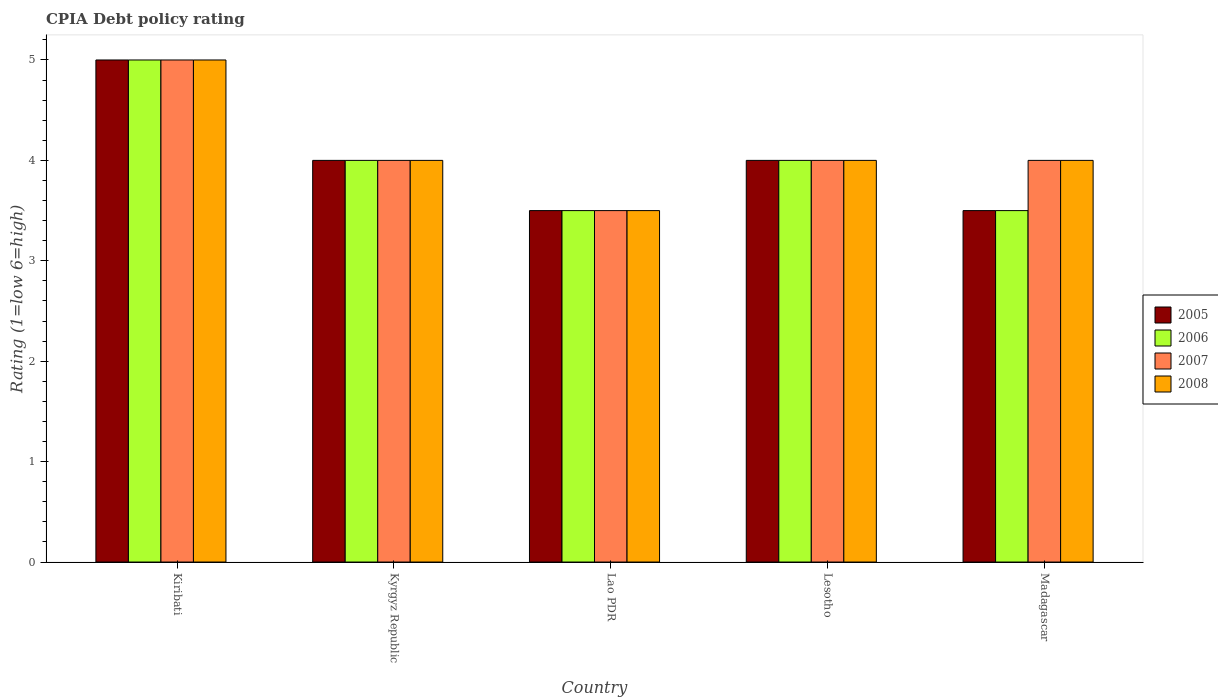How many groups of bars are there?
Make the answer very short. 5. Are the number of bars on each tick of the X-axis equal?
Give a very brief answer. Yes. How many bars are there on the 2nd tick from the left?
Make the answer very short. 4. How many bars are there on the 3rd tick from the right?
Offer a very short reply. 4. What is the label of the 1st group of bars from the left?
Provide a short and direct response. Kiribati. In how many cases, is the number of bars for a given country not equal to the number of legend labels?
Provide a short and direct response. 0. What is the CPIA rating in 2006 in Kyrgyz Republic?
Give a very brief answer. 4. In which country was the CPIA rating in 2008 maximum?
Your response must be concise. Kiribati. In which country was the CPIA rating in 2006 minimum?
Your response must be concise. Lao PDR. What is the total CPIA rating in 2005 in the graph?
Your answer should be very brief. 20. What is the difference between the CPIA rating in 2007 in Lao PDR and that in Madagascar?
Your answer should be compact. -0.5. What is the difference between the CPIA rating of/in 2007 and CPIA rating of/in 2005 in Madagascar?
Your answer should be very brief. 0.5. What is the ratio of the CPIA rating in 2007 in Lesotho to that in Madagascar?
Make the answer very short. 1. Is the CPIA rating in 2005 in Kiribati less than that in Lao PDR?
Give a very brief answer. No. What is the difference between the highest and the second highest CPIA rating in 2007?
Offer a very short reply. -1. What is the difference between the highest and the lowest CPIA rating in 2007?
Provide a succinct answer. 1.5. In how many countries, is the CPIA rating in 2006 greater than the average CPIA rating in 2006 taken over all countries?
Offer a terse response. 1. Is the sum of the CPIA rating in 2005 in Lao PDR and Madagascar greater than the maximum CPIA rating in 2006 across all countries?
Your response must be concise. Yes. Is it the case that in every country, the sum of the CPIA rating in 2006 and CPIA rating in 2008 is greater than the CPIA rating in 2005?
Your answer should be compact. Yes. How many bars are there?
Give a very brief answer. 20. Are all the bars in the graph horizontal?
Your answer should be very brief. No. How many countries are there in the graph?
Keep it short and to the point. 5. Are the values on the major ticks of Y-axis written in scientific E-notation?
Your answer should be compact. No. Where does the legend appear in the graph?
Provide a succinct answer. Center right. How are the legend labels stacked?
Your response must be concise. Vertical. What is the title of the graph?
Make the answer very short. CPIA Debt policy rating. Does "1981" appear as one of the legend labels in the graph?
Make the answer very short. No. What is the label or title of the X-axis?
Offer a very short reply. Country. What is the label or title of the Y-axis?
Make the answer very short. Rating (1=low 6=high). What is the Rating (1=low 6=high) of 2008 in Kiribati?
Your answer should be compact. 5. What is the Rating (1=low 6=high) in 2005 in Kyrgyz Republic?
Give a very brief answer. 4. What is the Rating (1=low 6=high) in 2007 in Kyrgyz Republic?
Ensure brevity in your answer.  4. What is the Rating (1=low 6=high) in 2008 in Kyrgyz Republic?
Your response must be concise. 4. What is the Rating (1=low 6=high) in 2005 in Lao PDR?
Provide a succinct answer. 3.5. What is the Rating (1=low 6=high) of 2006 in Lao PDR?
Offer a terse response. 3.5. What is the Rating (1=low 6=high) of 2008 in Lao PDR?
Give a very brief answer. 3.5. What is the Rating (1=low 6=high) of 2005 in Lesotho?
Your response must be concise. 4. What is the Rating (1=low 6=high) of 2007 in Lesotho?
Give a very brief answer. 4. What is the Rating (1=low 6=high) of 2005 in Madagascar?
Ensure brevity in your answer.  3.5. What is the Rating (1=low 6=high) in 2007 in Madagascar?
Offer a very short reply. 4. What is the Rating (1=low 6=high) in 2008 in Madagascar?
Offer a terse response. 4. Across all countries, what is the maximum Rating (1=low 6=high) in 2007?
Keep it short and to the point. 5. Across all countries, what is the minimum Rating (1=low 6=high) of 2005?
Provide a short and direct response. 3.5. Across all countries, what is the minimum Rating (1=low 6=high) of 2006?
Keep it short and to the point. 3.5. What is the total Rating (1=low 6=high) in 2005 in the graph?
Your answer should be compact. 20. What is the total Rating (1=low 6=high) in 2007 in the graph?
Offer a very short reply. 20.5. What is the difference between the Rating (1=low 6=high) of 2006 in Kiribati and that in Lao PDR?
Provide a succinct answer. 1.5. What is the difference between the Rating (1=low 6=high) of 2007 in Kiribati and that in Lao PDR?
Offer a terse response. 1.5. What is the difference between the Rating (1=low 6=high) of 2006 in Kiribati and that in Lesotho?
Your answer should be very brief. 1. What is the difference between the Rating (1=low 6=high) in 2007 in Kiribati and that in Lesotho?
Your answer should be compact. 1. What is the difference between the Rating (1=low 6=high) in 2005 in Kiribati and that in Madagascar?
Offer a terse response. 1.5. What is the difference between the Rating (1=low 6=high) of 2006 in Kiribati and that in Madagascar?
Make the answer very short. 1.5. What is the difference between the Rating (1=low 6=high) in 2008 in Kiribati and that in Madagascar?
Give a very brief answer. 1. What is the difference between the Rating (1=low 6=high) of 2005 in Kyrgyz Republic and that in Lao PDR?
Your response must be concise. 0.5. What is the difference between the Rating (1=low 6=high) in 2006 in Kyrgyz Republic and that in Lao PDR?
Your response must be concise. 0.5. What is the difference between the Rating (1=low 6=high) of 2006 in Kyrgyz Republic and that in Lesotho?
Provide a succinct answer. 0. What is the difference between the Rating (1=low 6=high) of 2008 in Kyrgyz Republic and that in Madagascar?
Ensure brevity in your answer.  0. What is the difference between the Rating (1=low 6=high) of 2006 in Lao PDR and that in Lesotho?
Offer a very short reply. -0.5. What is the difference between the Rating (1=low 6=high) in 2008 in Lao PDR and that in Lesotho?
Your response must be concise. -0.5. What is the difference between the Rating (1=low 6=high) in 2006 in Lao PDR and that in Madagascar?
Offer a terse response. 0. What is the difference between the Rating (1=low 6=high) in 2008 in Lao PDR and that in Madagascar?
Your answer should be compact. -0.5. What is the difference between the Rating (1=low 6=high) in 2006 in Lesotho and that in Madagascar?
Your answer should be very brief. 0.5. What is the difference between the Rating (1=low 6=high) in 2008 in Lesotho and that in Madagascar?
Give a very brief answer. 0. What is the difference between the Rating (1=low 6=high) in 2005 in Kiribati and the Rating (1=low 6=high) in 2008 in Kyrgyz Republic?
Ensure brevity in your answer.  1. What is the difference between the Rating (1=low 6=high) in 2006 in Kiribati and the Rating (1=low 6=high) in 2008 in Kyrgyz Republic?
Provide a short and direct response. 1. What is the difference between the Rating (1=low 6=high) of 2005 in Kiribati and the Rating (1=low 6=high) of 2006 in Lao PDR?
Offer a terse response. 1.5. What is the difference between the Rating (1=low 6=high) of 2005 in Kiribati and the Rating (1=low 6=high) of 2008 in Lao PDR?
Offer a terse response. 1.5. What is the difference between the Rating (1=low 6=high) of 2006 in Kiribati and the Rating (1=low 6=high) of 2007 in Lao PDR?
Your answer should be compact. 1.5. What is the difference between the Rating (1=low 6=high) in 2006 in Kiribati and the Rating (1=low 6=high) in 2008 in Lao PDR?
Your response must be concise. 1.5. What is the difference between the Rating (1=low 6=high) of 2007 in Kiribati and the Rating (1=low 6=high) of 2008 in Lao PDR?
Offer a terse response. 1.5. What is the difference between the Rating (1=low 6=high) of 2005 in Kiribati and the Rating (1=low 6=high) of 2007 in Lesotho?
Ensure brevity in your answer.  1. What is the difference between the Rating (1=low 6=high) in 2005 in Kiribati and the Rating (1=low 6=high) in 2008 in Lesotho?
Keep it short and to the point. 1. What is the difference between the Rating (1=low 6=high) in 2006 in Kiribati and the Rating (1=low 6=high) in 2007 in Lesotho?
Give a very brief answer. 1. What is the difference between the Rating (1=low 6=high) in 2007 in Kiribati and the Rating (1=low 6=high) in 2008 in Lesotho?
Make the answer very short. 1. What is the difference between the Rating (1=low 6=high) in 2005 in Kiribati and the Rating (1=low 6=high) in 2006 in Madagascar?
Provide a succinct answer. 1.5. What is the difference between the Rating (1=low 6=high) of 2005 in Kiribati and the Rating (1=low 6=high) of 2007 in Madagascar?
Offer a very short reply. 1. What is the difference between the Rating (1=low 6=high) in 2006 in Kiribati and the Rating (1=low 6=high) in 2007 in Madagascar?
Give a very brief answer. 1. What is the difference between the Rating (1=low 6=high) of 2006 in Kiribati and the Rating (1=low 6=high) of 2008 in Madagascar?
Your answer should be compact. 1. What is the difference between the Rating (1=low 6=high) in 2005 in Kyrgyz Republic and the Rating (1=low 6=high) in 2007 in Lao PDR?
Your answer should be very brief. 0.5. What is the difference between the Rating (1=low 6=high) in 2007 in Kyrgyz Republic and the Rating (1=low 6=high) in 2008 in Lao PDR?
Keep it short and to the point. 0.5. What is the difference between the Rating (1=low 6=high) of 2005 in Kyrgyz Republic and the Rating (1=low 6=high) of 2007 in Lesotho?
Keep it short and to the point. 0. What is the difference between the Rating (1=low 6=high) of 2006 in Kyrgyz Republic and the Rating (1=low 6=high) of 2008 in Lesotho?
Ensure brevity in your answer.  0. What is the difference between the Rating (1=low 6=high) in 2007 in Kyrgyz Republic and the Rating (1=low 6=high) in 2008 in Lesotho?
Provide a short and direct response. 0. What is the difference between the Rating (1=low 6=high) in 2005 in Kyrgyz Republic and the Rating (1=low 6=high) in 2006 in Madagascar?
Provide a succinct answer. 0.5. What is the difference between the Rating (1=low 6=high) of 2005 in Kyrgyz Republic and the Rating (1=low 6=high) of 2008 in Madagascar?
Your response must be concise. 0. What is the difference between the Rating (1=low 6=high) in 2006 in Kyrgyz Republic and the Rating (1=low 6=high) in 2007 in Madagascar?
Offer a terse response. 0. What is the difference between the Rating (1=low 6=high) of 2007 in Kyrgyz Republic and the Rating (1=low 6=high) of 2008 in Madagascar?
Provide a short and direct response. 0. What is the difference between the Rating (1=low 6=high) of 2005 in Lao PDR and the Rating (1=low 6=high) of 2006 in Lesotho?
Ensure brevity in your answer.  -0.5. What is the difference between the Rating (1=low 6=high) in 2007 in Lao PDR and the Rating (1=low 6=high) in 2008 in Lesotho?
Ensure brevity in your answer.  -0.5. What is the difference between the Rating (1=low 6=high) of 2006 in Lao PDR and the Rating (1=low 6=high) of 2008 in Madagascar?
Ensure brevity in your answer.  -0.5. What is the difference between the Rating (1=low 6=high) in 2005 in Lesotho and the Rating (1=low 6=high) in 2007 in Madagascar?
Ensure brevity in your answer.  0. What is the difference between the Rating (1=low 6=high) in 2006 in Lesotho and the Rating (1=low 6=high) in 2007 in Madagascar?
Your response must be concise. 0. What is the difference between the Rating (1=low 6=high) in 2007 in Lesotho and the Rating (1=low 6=high) in 2008 in Madagascar?
Offer a terse response. 0. What is the average Rating (1=low 6=high) in 2005 per country?
Your answer should be very brief. 4. What is the difference between the Rating (1=low 6=high) of 2005 and Rating (1=low 6=high) of 2008 in Kiribati?
Ensure brevity in your answer.  0. What is the difference between the Rating (1=low 6=high) of 2006 and Rating (1=low 6=high) of 2008 in Kiribati?
Give a very brief answer. 0. What is the difference between the Rating (1=low 6=high) in 2007 and Rating (1=low 6=high) in 2008 in Kiribati?
Ensure brevity in your answer.  0. What is the difference between the Rating (1=low 6=high) in 2005 and Rating (1=low 6=high) in 2008 in Kyrgyz Republic?
Your answer should be compact. 0. What is the difference between the Rating (1=low 6=high) in 2007 and Rating (1=low 6=high) in 2008 in Kyrgyz Republic?
Provide a short and direct response. 0. What is the difference between the Rating (1=low 6=high) in 2005 and Rating (1=low 6=high) in 2006 in Lao PDR?
Your answer should be compact. 0. What is the difference between the Rating (1=low 6=high) of 2005 and Rating (1=low 6=high) of 2007 in Lao PDR?
Ensure brevity in your answer.  0. What is the difference between the Rating (1=low 6=high) in 2006 and Rating (1=low 6=high) in 2007 in Lao PDR?
Your response must be concise. 0. What is the difference between the Rating (1=low 6=high) in 2006 and Rating (1=low 6=high) in 2008 in Lao PDR?
Your answer should be compact. 0. What is the difference between the Rating (1=low 6=high) in 2005 and Rating (1=low 6=high) in 2006 in Lesotho?
Offer a terse response. 0. What is the difference between the Rating (1=low 6=high) in 2005 and Rating (1=low 6=high) in 2008 in Lesotho?
Your answer should be compact. 0. What is the difference between the Rating (1=low 6=high) of 2006 and Rating (1=low 6=high) of 2007 in Lesotho?
Provide a short and direct response. 0. What is the difference between the Rating (1=low 6=high) of 2006 and Rating (1=low 6=high) of 2008 in Lesotho?
Give a very brief answer. 0. What is the difference between the Rating (1=low 6=high) of 2006 and Rating (1=low 6=high) of 2007 in Madagascar?
Provide a short and direct response. -0.5. What is the difference between the Rating (1=low 6=high) of 2007 and Rating (1=low 6=high) of 2008 in Madagascar?
Make the answer very short. 0. What is the ratio of the Rating (1=low 6=high) of 2007 in Kiribati to that in Kyrgyz Republic?
Offer a very short reply. 1.25. What is the ratio of the Rating (1=low 6=high) in 2008 in Kiribati to that in Kyrgyz Republic?
Make the answer very short. 1.25. What is the ratio of the Rating (1=low 6=high) of 2005 in Kiribati to that in Lao PDR?
Provide a succinct answer. 1.43. What is the ratio of the Rating (1=low 6=high) in 2006 in Kiribati to that in Lao PDR?
Give a very brief answer. 1.43. What is the ratio of the Rating (1=low 6=high) of 2007 in Kiribati to that in Lao PDR?
Give a very brief answer. 1.43. What is the ratio of the Rating (1=low 6=high) in 2008 in Kiribati to that in Lao PDR?
Make the answer very short. 1.43. What is the ratio of the Rating (1=low 6=high) of 2006 in Kiribati to that in Lesotho?
Ensure brevity in your answer.  1.25. What is the ratio of the Rating (1=low 6=high) of 2007 in Kiribati to that in Lesotho?
Offer a very short reply. 1.25. What is the ratio of the Rating (1=low 6=high) in 2008 in Kiribati to that in Lesotho?
Provide a succinct answer. 1.25. What is the ratio of the Rating (1=low 6=high) in 2005 in Kiribati to that in Madagascar?
Your answer should be very brief. 1.43. What is the ratio of the Rating (1=low 6=high) in 2006 in Kiribati to that in Madagascar?
Your response must be concise. 1.43. What is the ratio of the Rating (1=low 6=high) of 2007 in Kiribati to that in Madagascar?
Your response must be concise. 1.25. What is the ratio of the Rating (1=low 6=high) of 2005 in Kyrgyz Republic to that in Lao PDR?
Offer a terse response. 1.14. What is the ratio of the Rating (1=low 6=high) in 2006 in Kyrgyz Republic to that in Lao PDR?
Give a very brief answer. 1.14. What is the ratio of the Rating (1=low 6=high) of 2006 in Kyrgyz Republic to that in Lesotho?
Make the answer very short. 1. What is the ratio of the Rating (1=low 6=high) in 2005 in Kyrgyz Republic to that in Madagascar?
Ensure brevity in your answer.  1.14. What is the ratio of the Rating (1=low 6=high) in 2006 in Kyrgyz Republic to that in Madagascar?
Your answer should be compact. 1.14. What is the ratio of the Rating (1=low 6=high) of 2007 in Kyrgyz Republic to that in Madagascar?
Your answer should be very brief. 1. What is the ratio of the Rating (1=low 6=high) in 2008 in Kyrgyz Republic to that in Madagascar?
Provide a succinct answer. 1. What is the ratio of the Rating (1=low 6=high) in 2005 in Lao PDR to that in Lesotho?
Offer a terse response. 0.88. What is the ratio of the Rating (1=low 6=high) of 2006 in Lao PDR to that in Lesotho?
Provide a short and direct response. 0.88. What is the ratio of the Rating (1=low 6=high) in 2005 in Lao PDR to that in Madagascar?
Your answer should be compact. 1. What is the ratio of the Rating (1=low 6=high) of 2006 in Lesotho to that in Madagascar?
Keep it short and to the point. 1.14. What is the ratio of the Rating (1=low 6=high) of 2007 in Lesotho to that in Madagascar?
Ensure brevity in your answer.  1. What is the difference between the highest and the second highest Rating (1=low 6=high) in 2006?
Your answer should be very brief. 1. What is the difference between the highest and the second highest Rating (1=low 6=high) of 2007?
Offer a terse response. 1. What is the difference between the highest and the second highest Rating (1=low 6=high) in 2008?
Provide a succinct answer. 1. What is the difference between the highest and the lowest Rating (1=low 6=high) in 2005?
Make the answer very short. 1.5. What is the difference between the highest and the lowest Rating (1=low 6=high) in 2006?
Make the answer very short. 1.5. What is the difference between the highest and the lowest Rating (1=low 6=high) of 2007?
Ensure brevity in your answer.  1.5. What is the difference between the highest and the lowest Rating (1=low 6=high) of 2008?
Your answer should be compact. 1.5. 